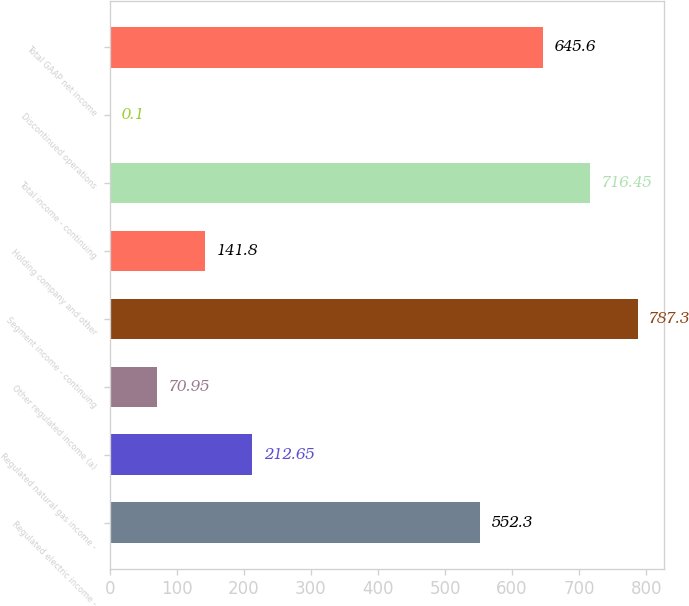<chart> <loc_0><loc_0><loc_500><loc_500><bar_chart><fcel>Regulated electric income -<fcel>Regulated natural gas income -<fcel>Other regulated income (a)<fcel>Segment income - continuing<fcel>Holding company and other<fcel>Total income - continuing<fcel>Discontinued operations<fcel>Total GAAP net income<nl><fcel>552.3<fcel>212.65<fcel>70.95<fcel>787.3<fcel>141.8<fcel>716.45<fcel>0.1<fcel>645.6<nl></chart> 